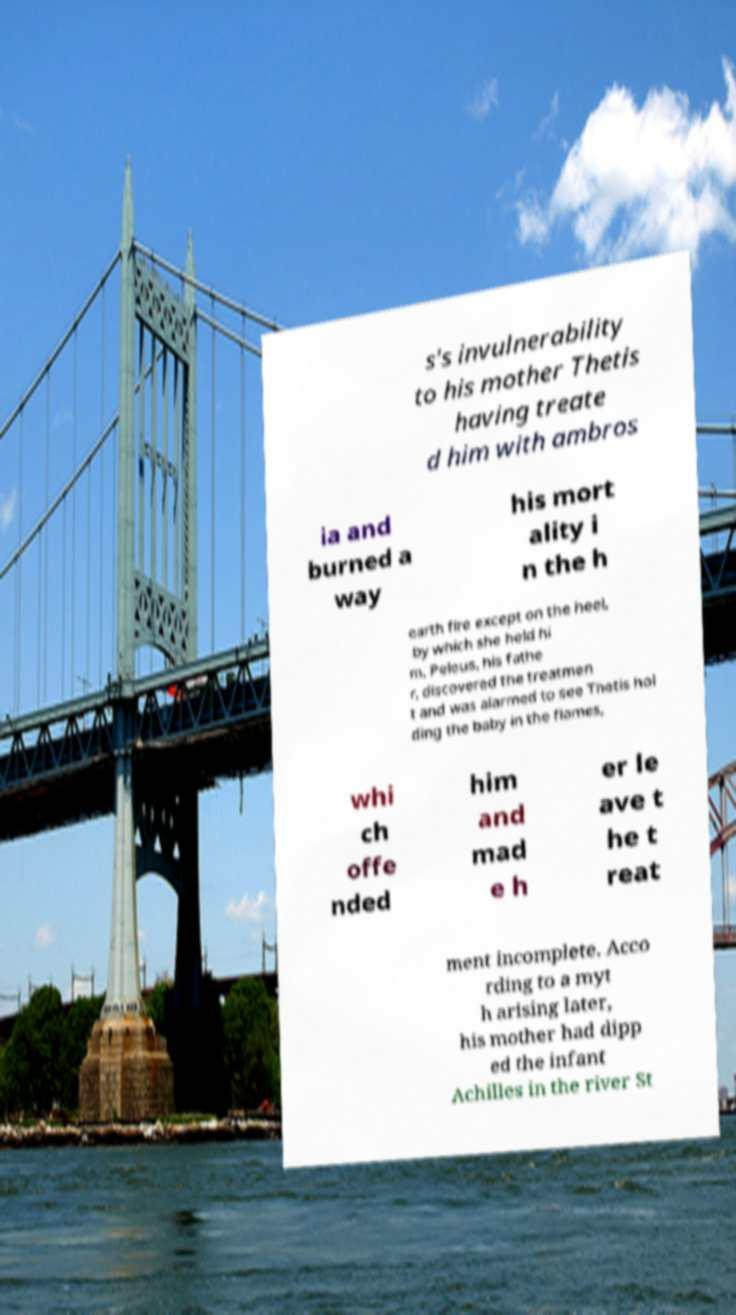Could you extract and type out the text from this image? s's invulnerability to his mother Thetis having treate d him with ambros ia and burned a way his mort ality i n the h earth fire except on the heel, by which she held hi m. Peleus, his fathe r, discovered the treatmen t and was alarmed to see Thetis hol ding the baby in the flames, whi ch offe nded him and mad e h er le ave t he t reat ment incomplete. Acco rding to a myt h arising later, his mother had dipp ed the infant Achilles in the river St 